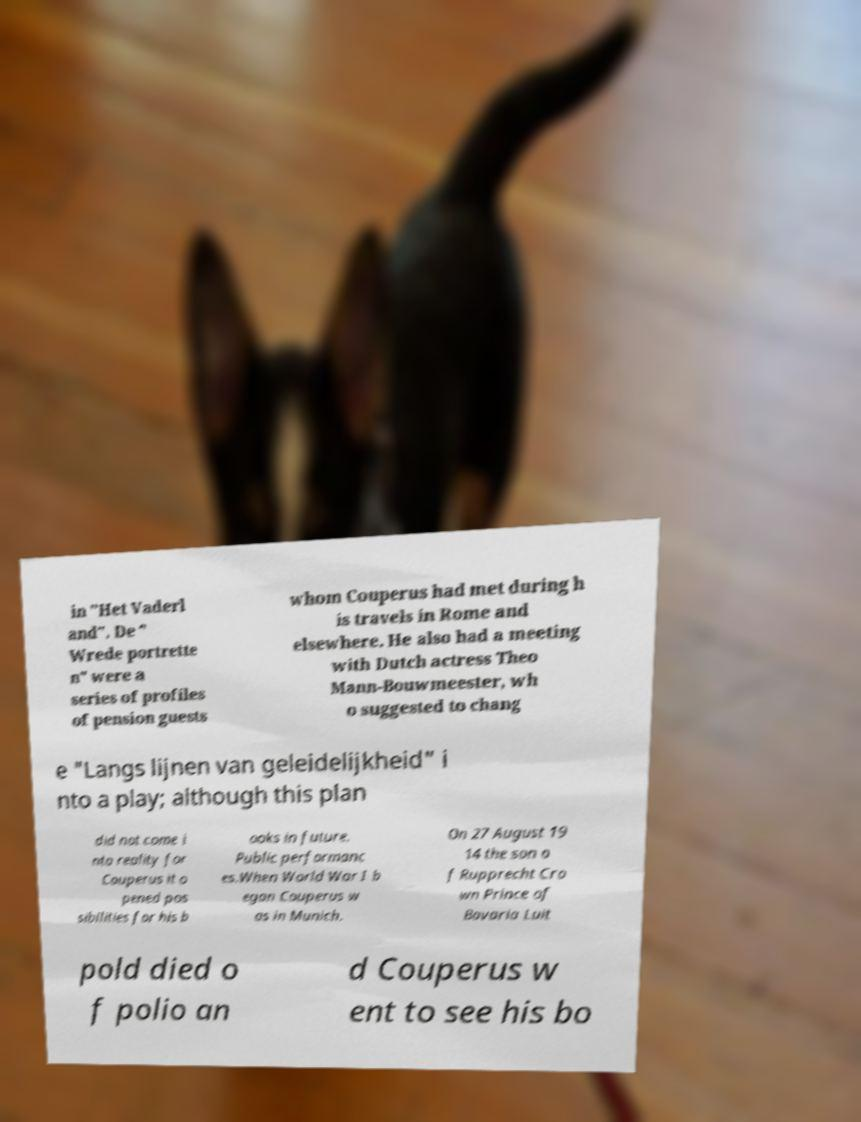I need the written content from this picture converted into text. Can you do that? in "Het Vaderl and". De " Wrede portrette n" were a series of profiles of pension guests whom Couperus had met during h is travels in Rome and elsewhere. He also had a meeting with Dutch actress Theo Mann-Bouwmeester, wh o suggested to chang e "Langs lijnen van geleidelijkheid" i nto a play; although this plan did not come i nto reality for Couperus it o pened pos sibilities for his b ooks in future. Public performanc es.When World War I b egan Couperus w as in Munich. On 27 August 19 14 the son o f Rupprecht Cro wn Prince of Bavaria Luit pold died o f polio an d Couperus w ent to see his bo 